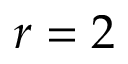Convert formula to latex. <formula><loc_0><loc_0><loc_500><loc_500>r = 2</formula> 